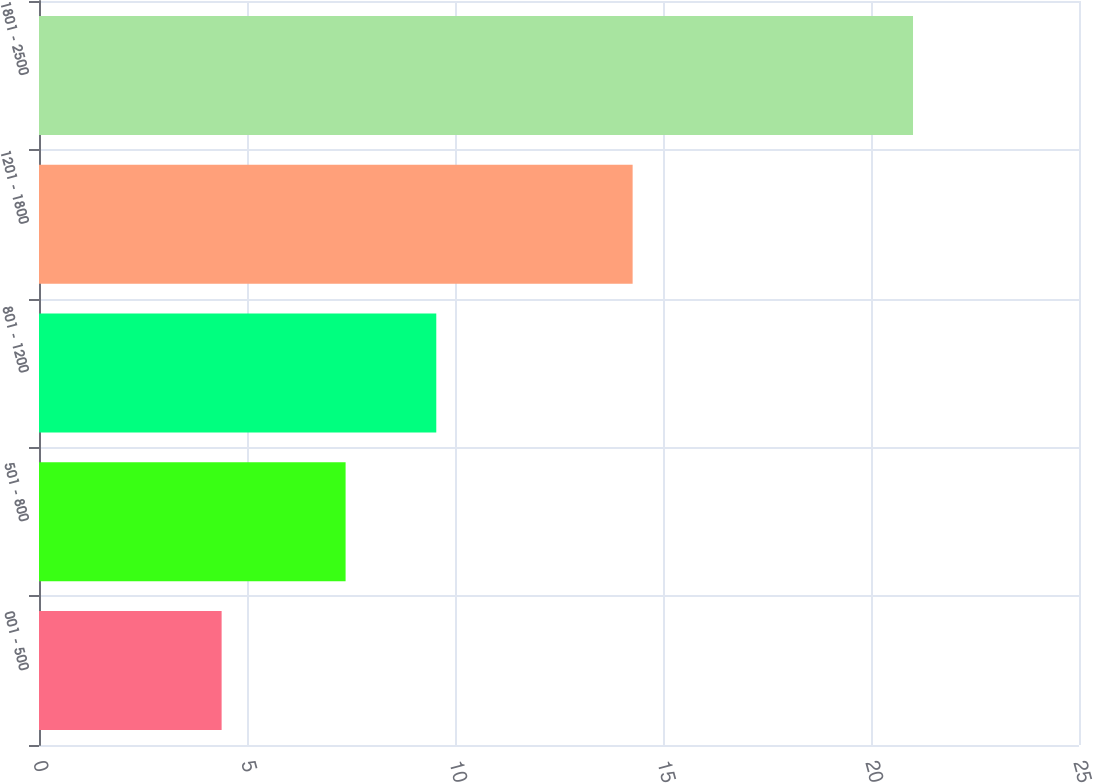Convert chart. <chart><loc_0><loc_0><loc_500><loc_500><bar_chart><fcel>001 - 500<fcel>501 - 800<fcel>801 - 1200<fcel>1201 - 1800<fcel>1801 - 2500<nl><fcel>4.39<fcel>7.37<fcel>9.55<fcel>14.27<fcel>21.01<nl></chart> 